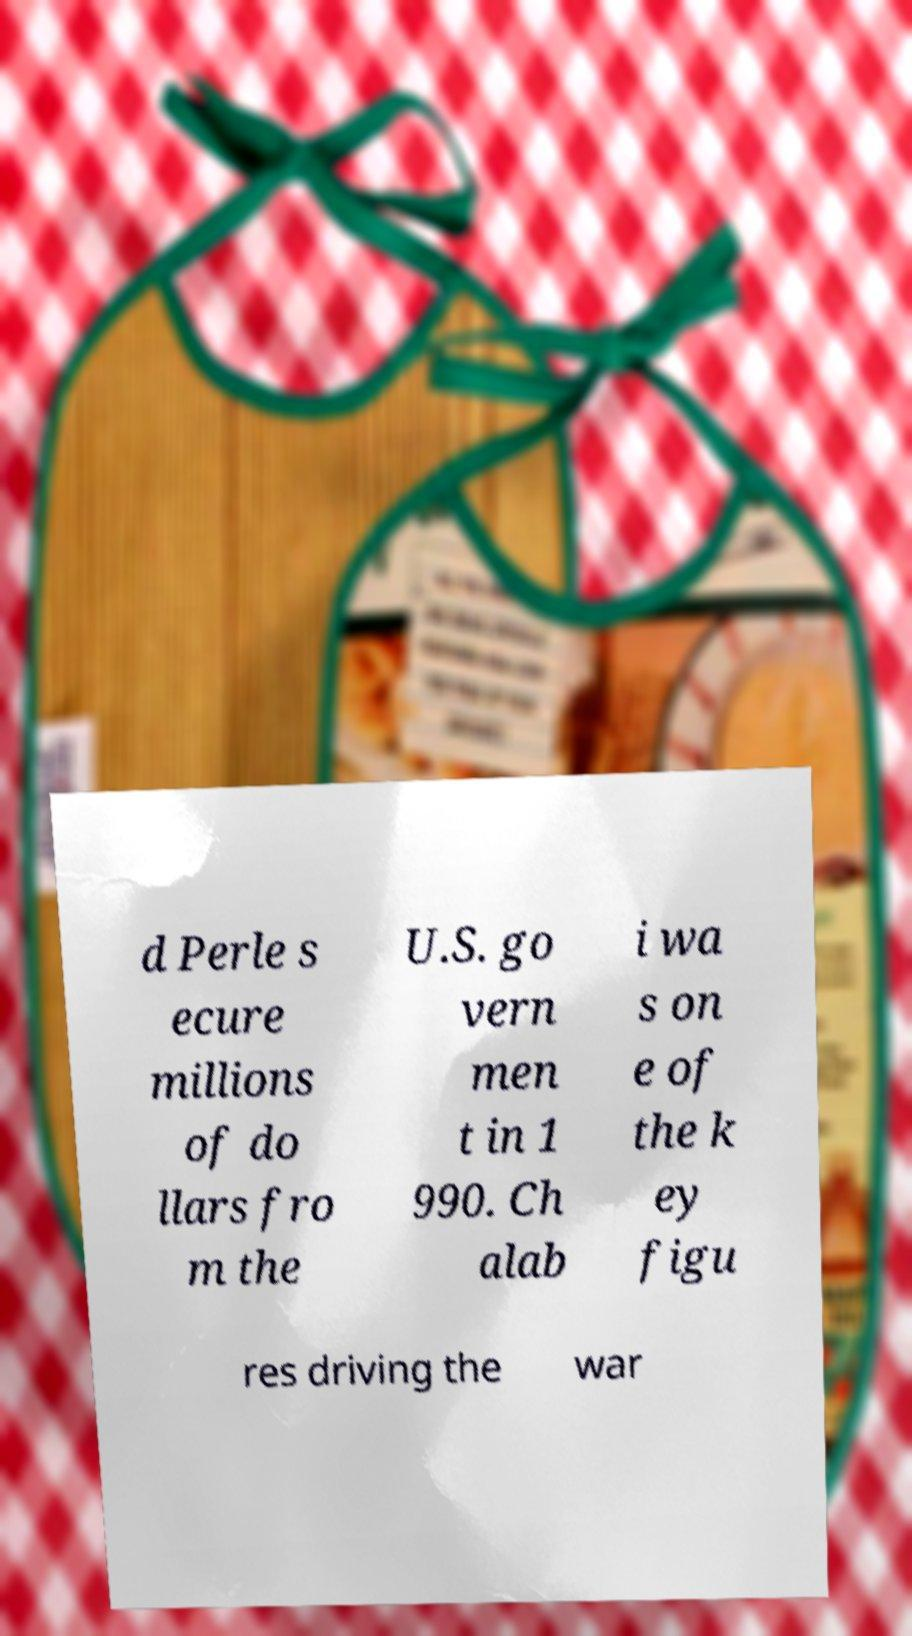Can you read and provide the text displayed in the image?This photo seems to have some interesting text. Can you extract and type it out for me? d Perle s ecure millions of do llars fro m the U.S. go vern men t in 1 990. Ch alab i wa s on e of the k ey figu res driving the war 